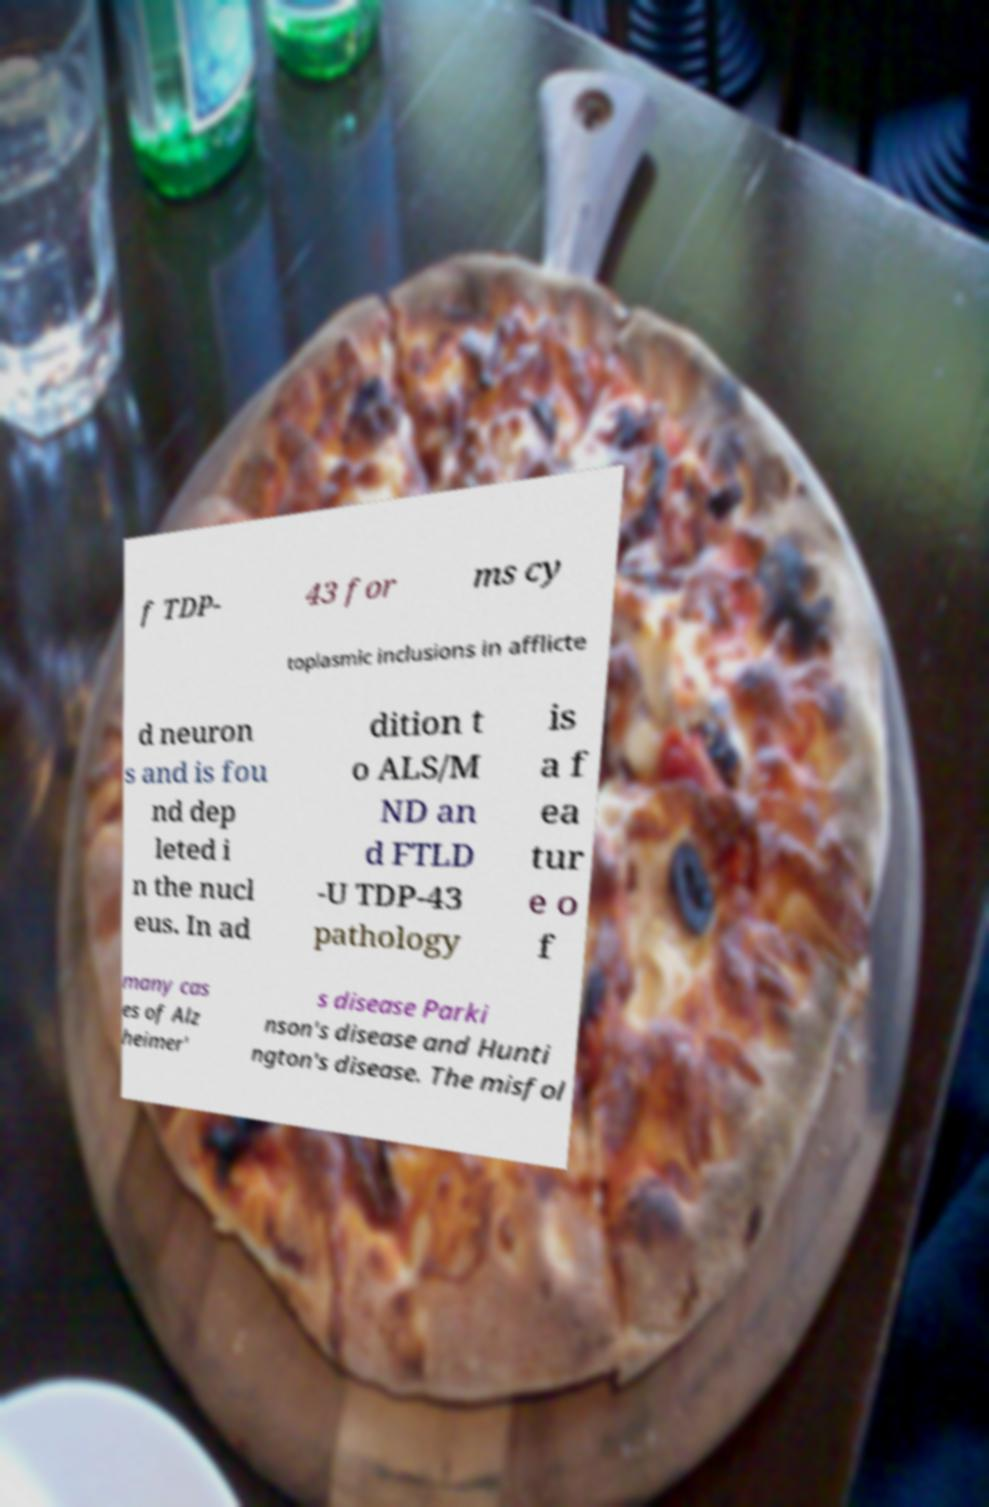What messages or text are displayed in this image? I need them in a readable, typed format. f TDP- 43 for ms cy toplasmic inclusions in afflicte d neuron s and is fou nd dep leted i n the nucl eus. In ad dition t o ALS/M ND an d FTLD -U TDP-43 pathology is a f ea tur e o f many cas es of Alz heimer' s disease Parki nson's disease and Hunti ngton's disease. The misfol 